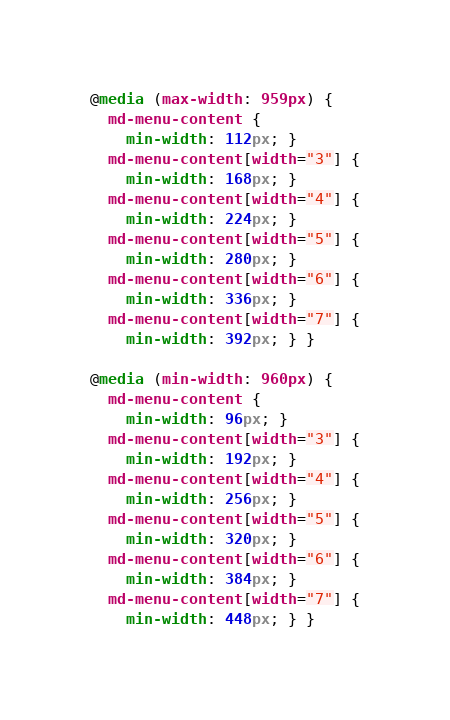<code> <loc_0><loc_0><loc_500><loc_500><_CSS_>@media (max-width: 959px) {
  md-menu-content {
    min-width: 112px; }
  md-menu-content[width="3"] {
    min-width: 168px; }
  md-menu-content[width="4"] {
    min-width: 224px; }
  md-menu-content[width="5"] {
    min-width: 280px; }
  md-menu-content[width="6"] {
    min-width: 336px; }
  md-menu-content[width="7"] {
    min-width: 392px; } }

@media (min-width: 960px) {
  md-menu-content {
    min-width: 96px; }
  md-menu-content[width="3"] {
    min-width: 192px; }
  md-menu-content[width="4"] {
    min-width: 256px; }
  md-menu-content[width="5"] {
    min-width: 320px; }
  md-menu-content[width="6"] {
    min-width: 384px; }
  md-menu-content[width="7"] {
    min-width: 448px; } }
</code> 